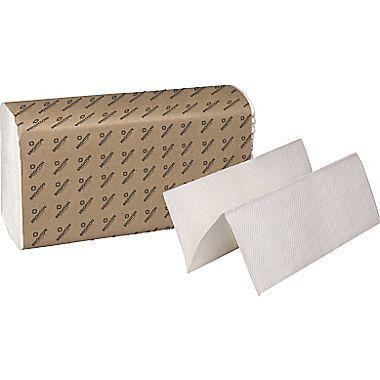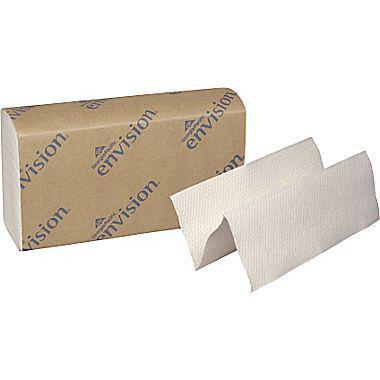The first image is the image on the left, the second image is the image on the right. For the images displayed, is the sentence "At least one image features one accordion-folded paper towel in front of a stack of folded white paper towels wrapped in printed paper." factually correct? Answer yes or no. Yes. 